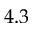Convert formula to latex. <formula><loc_0><loc_0><loc_500><loc_500>4 . 3</formula> 